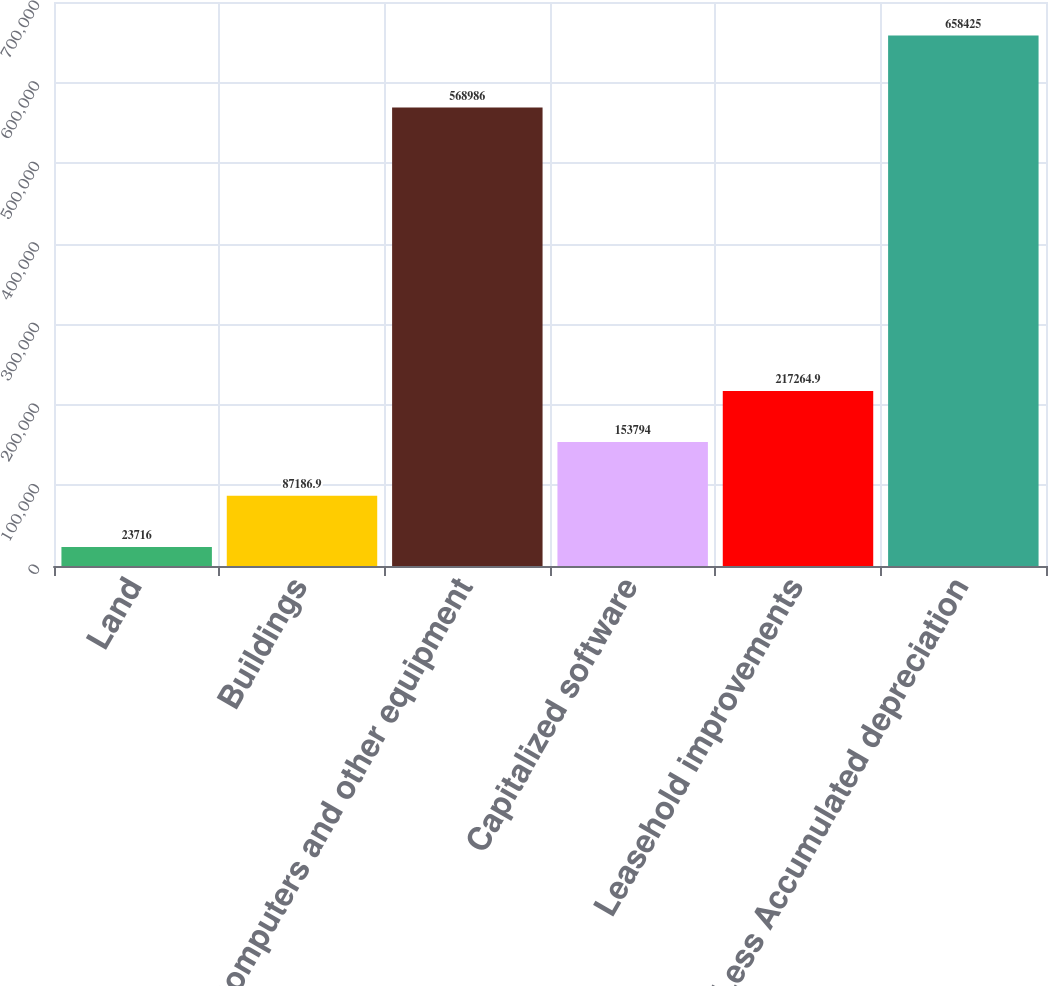Convert chart to OTSL. <chart><loc_0><loc_0><loc_500><loc_500><bar_chart><fcel>Land<fcel>Buildings<fcel>Computers and other equipment<fcel>Capitalized software<fcel>Leasehold improvements<fcel>Less Accumulated depreciation<nl><fcel>23716<fcel>87186.9<fcel>568986<fcel>153794<fcel>217265<fcel>658425<nl></chart> 